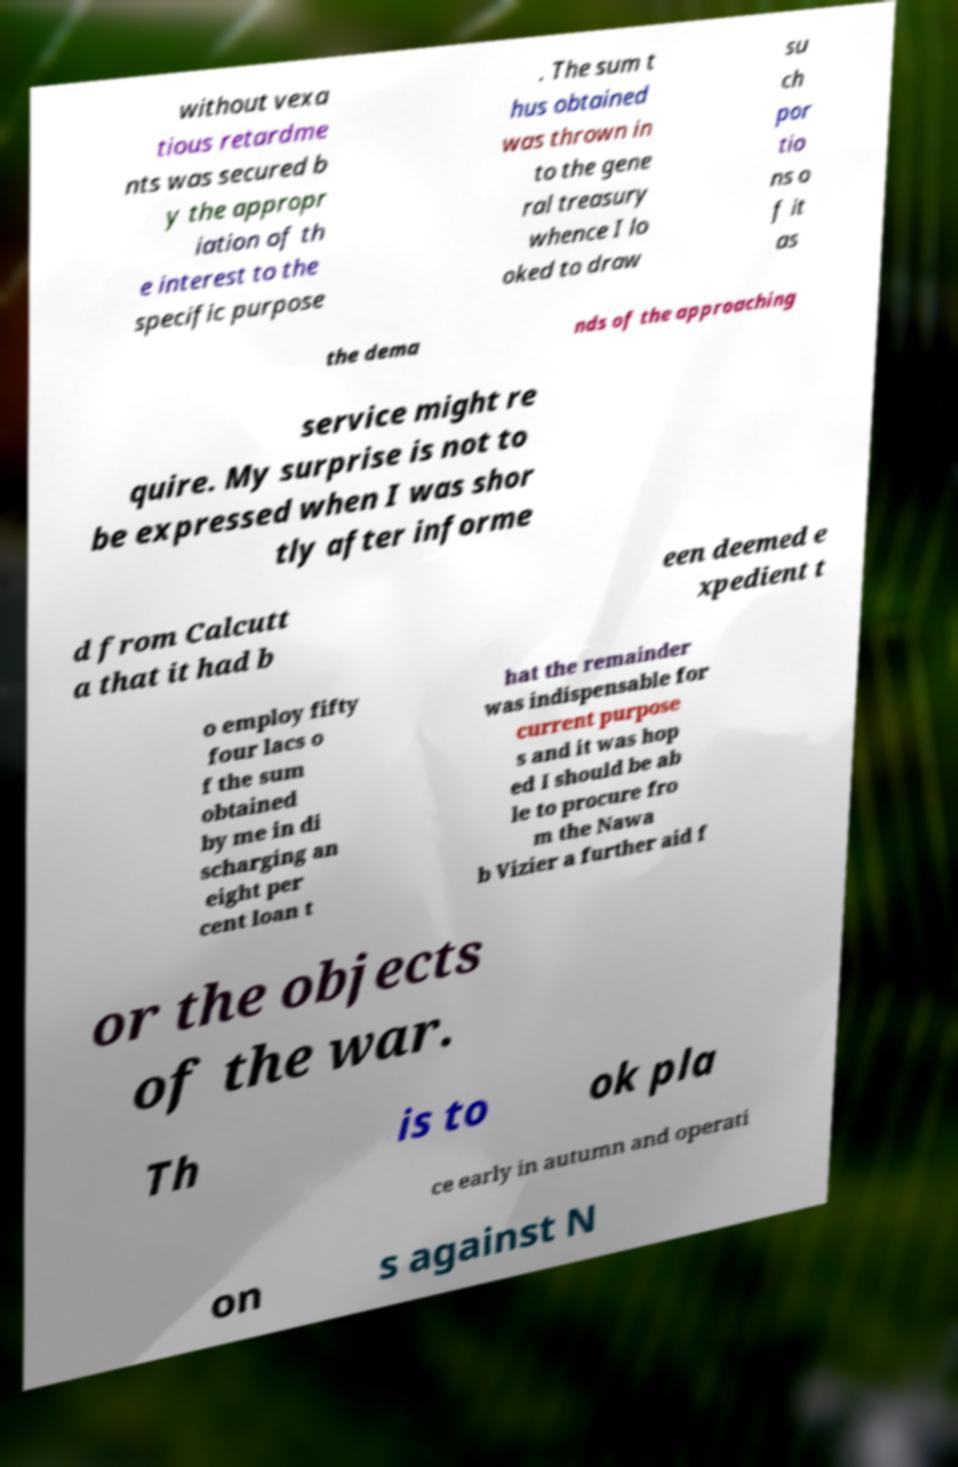Could you extract and type out the text from this image? without vexa tious retardme nts was secured b y the appropr iation of th e interest to the specific purpose . The sum t hus obtained was thrown in to the gene ral treasury whence I lo oked to draw su ch por tio ns o f it as the dema nds of the approaching service might re quire. My surprise is not to be expressed when I was shor tly after informe d from Calcutt a that it had b een deemed e xpedient t o employ fifty four lacs o f the sum obtained by me in di scharging an eight per cent loan t hat the remainder was indispensable for current purpose s and it was hop ed I should be ab le to procure fro m the Nawa b Vizier a further aid f or the objects of the war. Th is to ok pla ce early in autumn and operati on s against N 